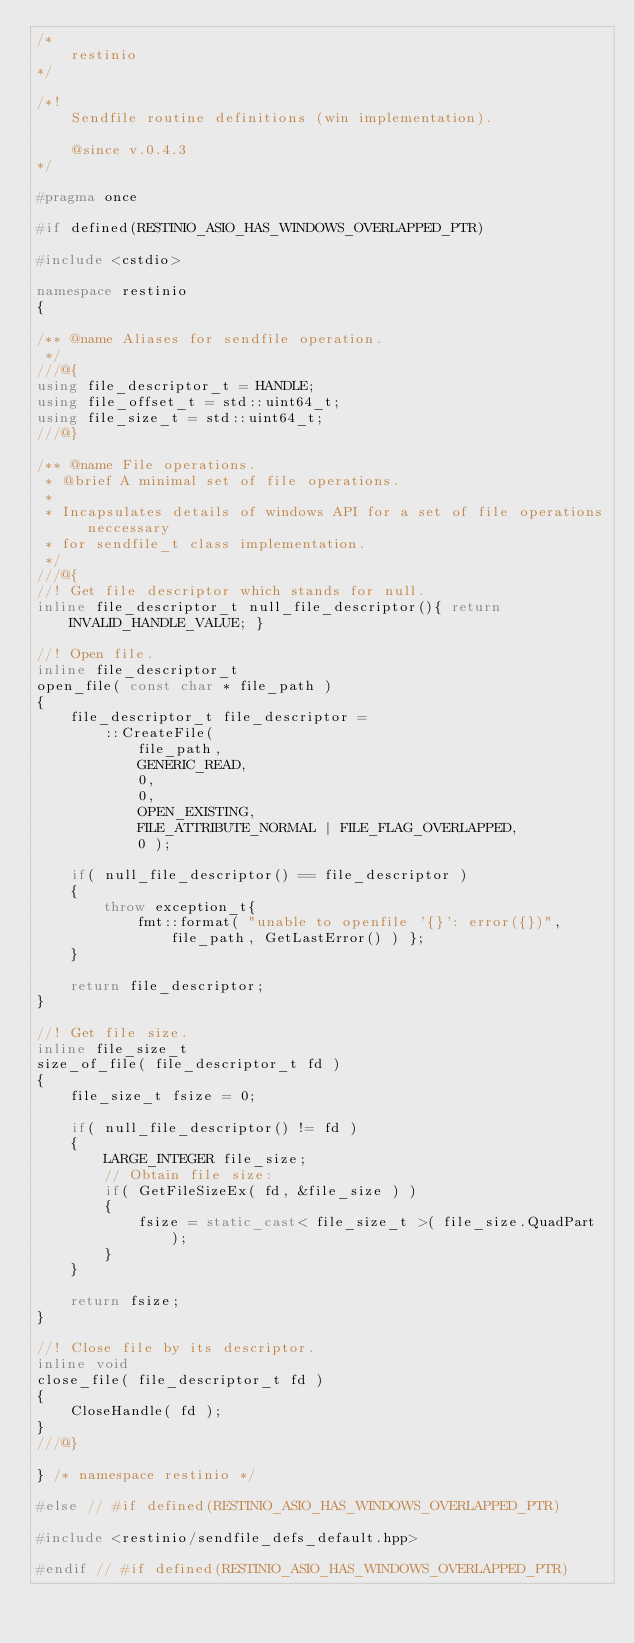<code> <loc_0><loc_0><loc_500><loc_500><_C++_>/*
	restinio
*/

/*!
	Sendfile routine definitions (win implementation).

	@since v.0.4.3
*/

#pragma once

#if defined(RESTINIO_ASIO_HAS_WINDOWS_OVERLAPPED_PTR)

#include <cstdio>

namespace restinio
{

/** @name Aliases for sendfile operation.
 */
///@{
using file_descriptor_t = HANDLE;
using file_offset_t = std::uint64_t;
using file_size_t = std::uint64_t;
///@}

/** @name File operations.
 * @brief A minimal set of file operations.
 *
 * Incapsulates details of windows API for a set of file operations neccessary
 * for sendfile_t class implementation.
 */
///@{
//! Get file descriptor which stands for null.
inline file_descriptor_t null_file_descriptor(){ return INVALID_HANDLE_VALUE; }

//! Open file.
inline file_descriptor_t
open_file( const char * file_path )
{
	file_descriptor_t file_descriptor =
		::CreateFile(
			file_path,
			GENERIC_READ,
			0,
			0,
			OPEN_EXISTING,
			FILE_ATTRIBUTE_NORMAL | FILE_FLAG_OVERLAPPED,
			0 );

	if( null_file_descriptor() == file_descriptor )
	{
		throw exception_t{
			fmt::format( "unable to openfile '{}': error({})", file_path, GetLastError() ) };
	}

	return file_descriptor;
}

//! Get file size.
inline file_size_t
size_of_file( file_descriptor_t fd )
{
	file_size_t fsize = 0;

	if( null_file_descriptor() != fd )
	{
		LARGE_INTEGER file_size;
		// Obtain file size:
		if( GetFileSizeEx( fd, &file_size ) )
		{
			fsize = static_cast< file_size_t >( file_size.QuadPart );
		}
	}

	return fsize;
}

//! Close file by its descriptor.
inline void
close_file( file_descriptor_t fd )
{
	CloseHandle( fd );
}
///@}

} /* namespace restinio */

#else // #if defined(RESTINIO_ASIO_HAS_WINDOWS_OVERLAPPED_PTR)

#include <restinio/sendfile_defs_default.hpp>

#endif // #if defined(RESTINIO_ASIO_HAS_WINDOWS_OVERLAPPED_PTR)
</code> 